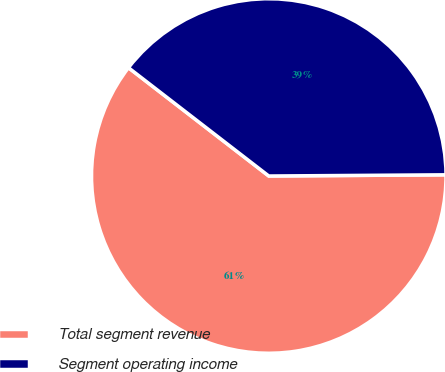<chart> <loc_0><loc_0><loc_500><loc_500><pie_chart><fcel>Total segment revenue<fcel>Segment operating income<nl><fcel>60.57%<fcel>39.43%<nl></chart> 